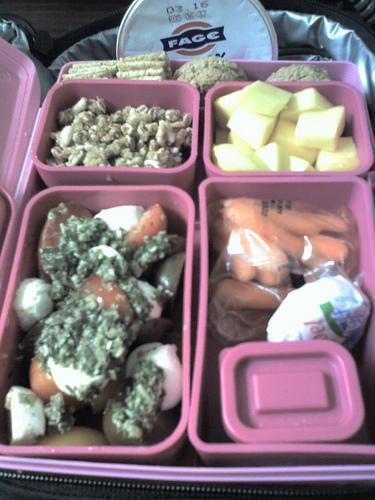What does the company whose logo appears at the top specialize in?
Select the correct answer and articulate reasoning with the following format: 'Answer: answer
Rationale: rationale.'
Options: Yogurt, pizza, hot dogs, broccoli. Answer: yogurt.
Rationale: The logo on the top is for fage who makes the greek product. 